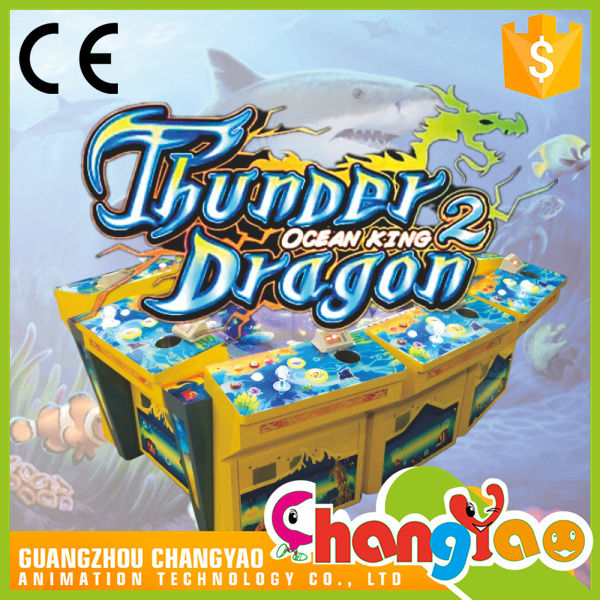What type of game does "Thunder Dragon 2 Ocean King" imply, based on the imagery and controls visible? The vibrant visuals and controls observed on the "Thunder Dragon 2 Ocean King" arcade machine suggest it's an engaging multiplayer shooting or fishing game designed for simultaneous play by several participants. Each player station, equipped with a joystick and firing buttons, indicates a personal gameplay zone where participants can interact with the dynamic ocean-scape displayed across the large central screen. Players likely compete against one another to capture or shoot various sea creatures, including mythical dragons and sharks, in an underwater adventure, possibly racking up points to obtain high scores or earn in-game rewards. The colorful oceanic graphics, combined with the game's title, evoke a thrilling competition to become the ultimate 'Ocean King' among peers. 